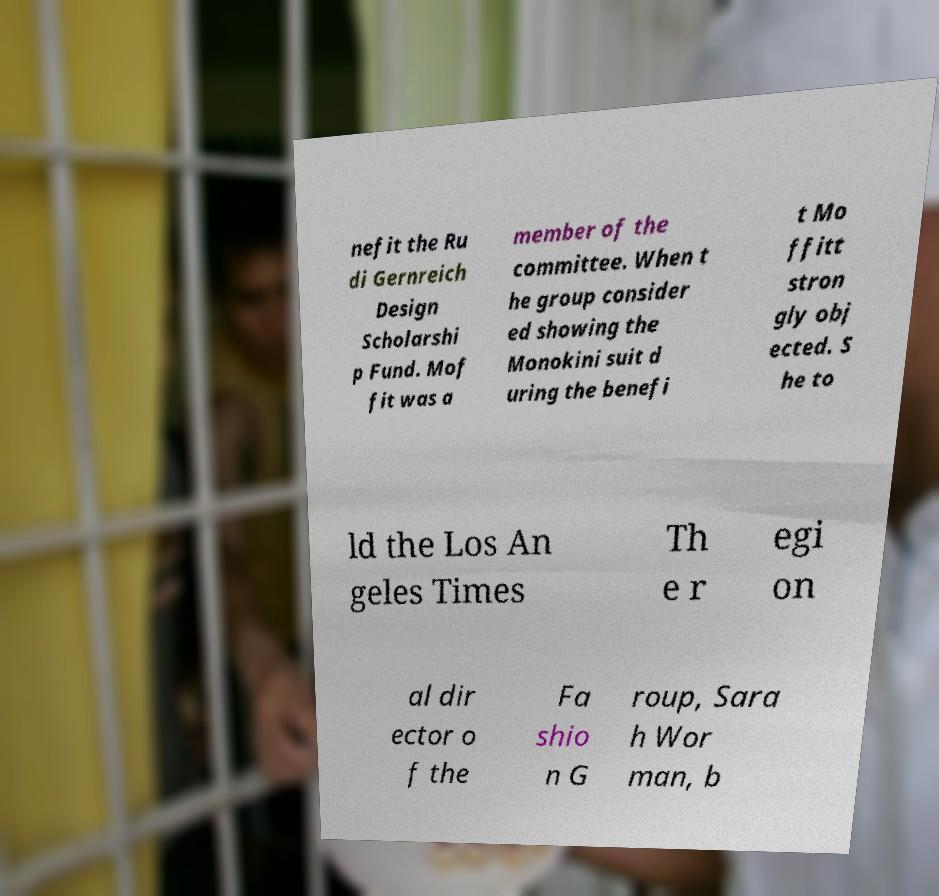Can you read and provide the text displayed in the image?This photo seems to have some interesting text. Can you extract and type it out for me? nefit the Ru di Gernreich Design Scholarshi p Fund. Mof fit was a member of the committee. When t he group consider ed showing the Monokini suit d uring the benefi t Mo ffitt stron gly obj ected. S he to ld the Los An geles Times Th e r egi on al dir ector o f the Fa shio n G roup, Sara h Wor man, b 